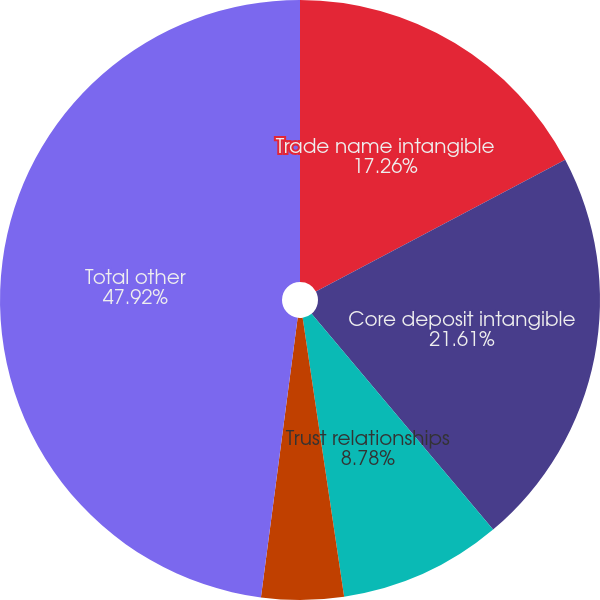<chart> <loc_0><loc_0><loc_500><loc_500><pie_chart><fcel>Trade name intangible<fcel>Core deposit intangible<fcel>Trust relationships<fcel>Insurance relationships<fcel>Total other<nl><fcel>17.26%<fcel>21.61%<fcel>8.78%<fcel>4.43%<fcel>47.92%<nl></chart> 